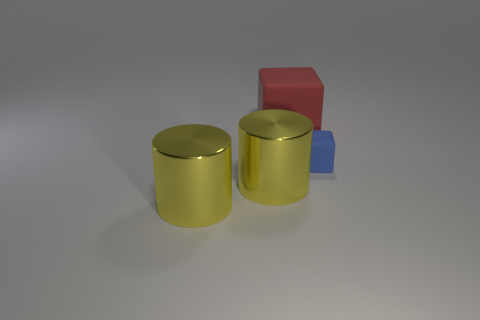Add 1 yellow metallic cylinders. How many objects exist? 5 Subtract 0 brown cubes. How many objects are left? 4 Subtract all yellow cylinders. Subtract all shiny cylinders. How many objects are left? 0 Add 3 metallic cylinders. How many metallic cylinders are left? 5 Add 2 large yellow metallic objects. How many large yellow metallic objects exist? 4 